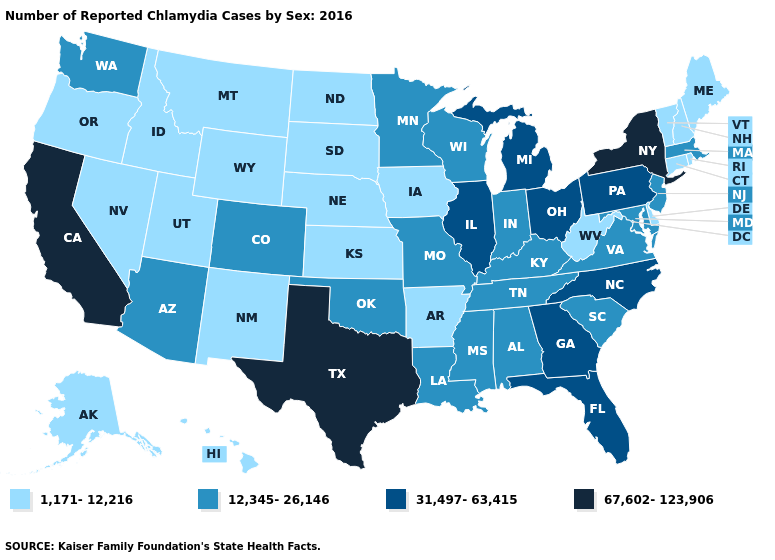Does Utah have the highest value in the West?
Write a very short answer. No. What is the highest value in the USA?
Give a very brief answer. 67,602-123,906. How many symbols are there in the legend?
Be succinct. 4. What is the highest value in the USA?
Short answer required. 67,602-123,906. What is the value of Texas?
Write a very short answer. 67,602-123,906. What is the value of Nebraska?
Answer briefly. 1,171-12,216. What is the value of North Carolina?
Answer briefly. 31,497-63,415. What is the value of Minnesota?
Concise answer only. 12,345-26,146. Among the states that border North Carolina , does Georgia have the highest value?
Keep it brief. Yes. Does Texas have the highest value in the South?
Write a very short answer. Yes. Does Nevada have the highest value in the USA?
Keep it brief. No. What is the value of Nevada?
Concise answer only. 1,171-12,216. Name the states that have a value in the range 12,345-26,146?
Be succinct. Alabama, Arizona, Colorado, Indiana, Kentucky, Louisiana, Maryland, Massachusetts, Minnesota, Mississippi, Missouri, New Jersey, Oklahoma, South Carolina, Tennessee, Virginia, Washington, Wisconsin. Name the states that have a value in the range 1,171-12,216?
Be succinct. Alaska, Arkansas, Connecticut, Delaware, Hawaii, Idaho, Iowa, Kansas, Maine, Montana, Nebraska, Nevada, New Hampshire, New Mexico, North Dakota, Oregon, Rhode Island, South Dakota, Utah, Vermont, West Virginia, Wyoming. Which states have the lowest value in the Northeast?
Concise answer only. Connecticut, Maine, New Hampshire, Rhode Island, Vermont. 